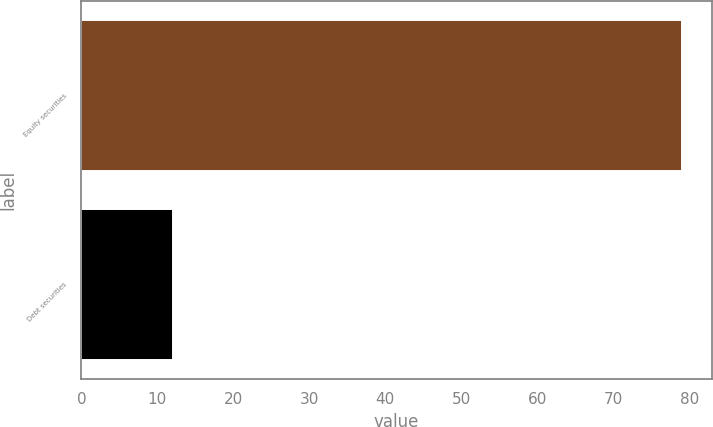Convert chart to OTSL. <chart><loc_0><loc_0><loc_500><loc_500><bar_chart><fcel>Equity securities<fcel>Debt securities<nl><fcel>79<fcel>12<nl></chart> 